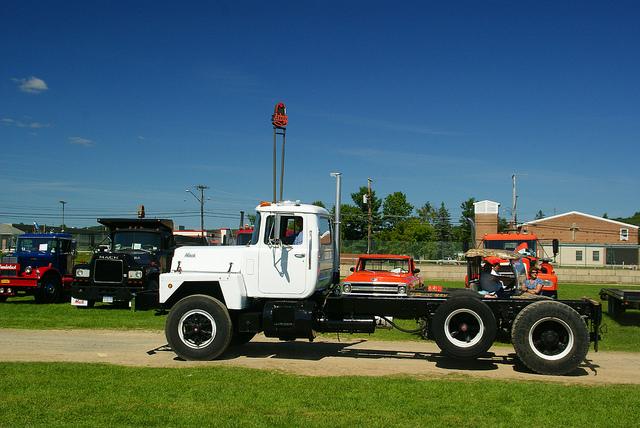Is there a shadow near the truck?
Give a very brief answer. Yes. What color is the truck?
Be succinct. White. Is it cloudy?
Be succinct. No. How many tires are on the truck?
Give a very brief answer. 6. What season is this?
Concise answer only. Summer. Is the man racing with the tractor?
Short answer required. No. 